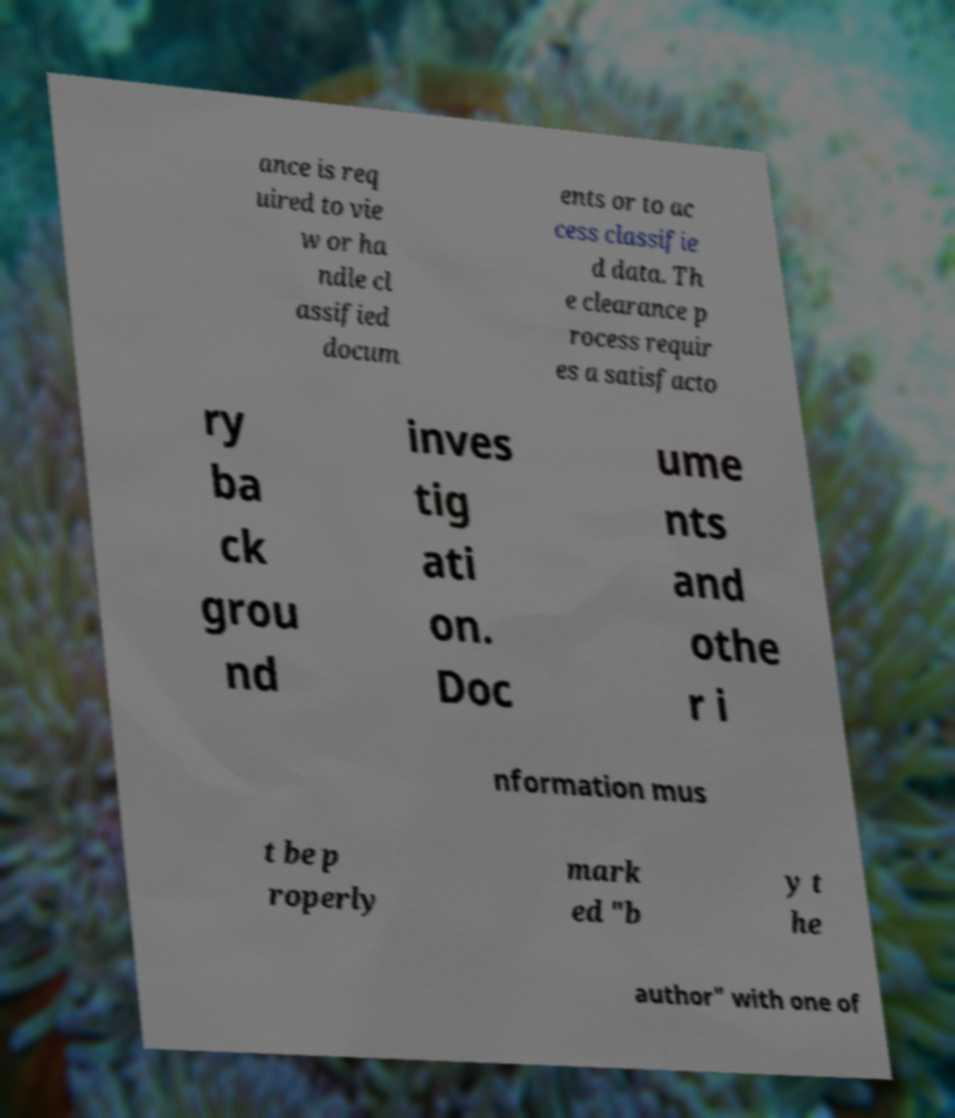There's text embedded in this image that I need extracted. Can you transcribe it verbatim? ance is req uired to vie w or ha ndle cl assified docum ents or to ac cess classifie d data. Th e clearance p rocess requir es a satisfacto ry ba ck grou nd inves tig ati on. Doc ume nts and othe r i nformation mus t be p roperly mark ed "b y t he author" with one of 